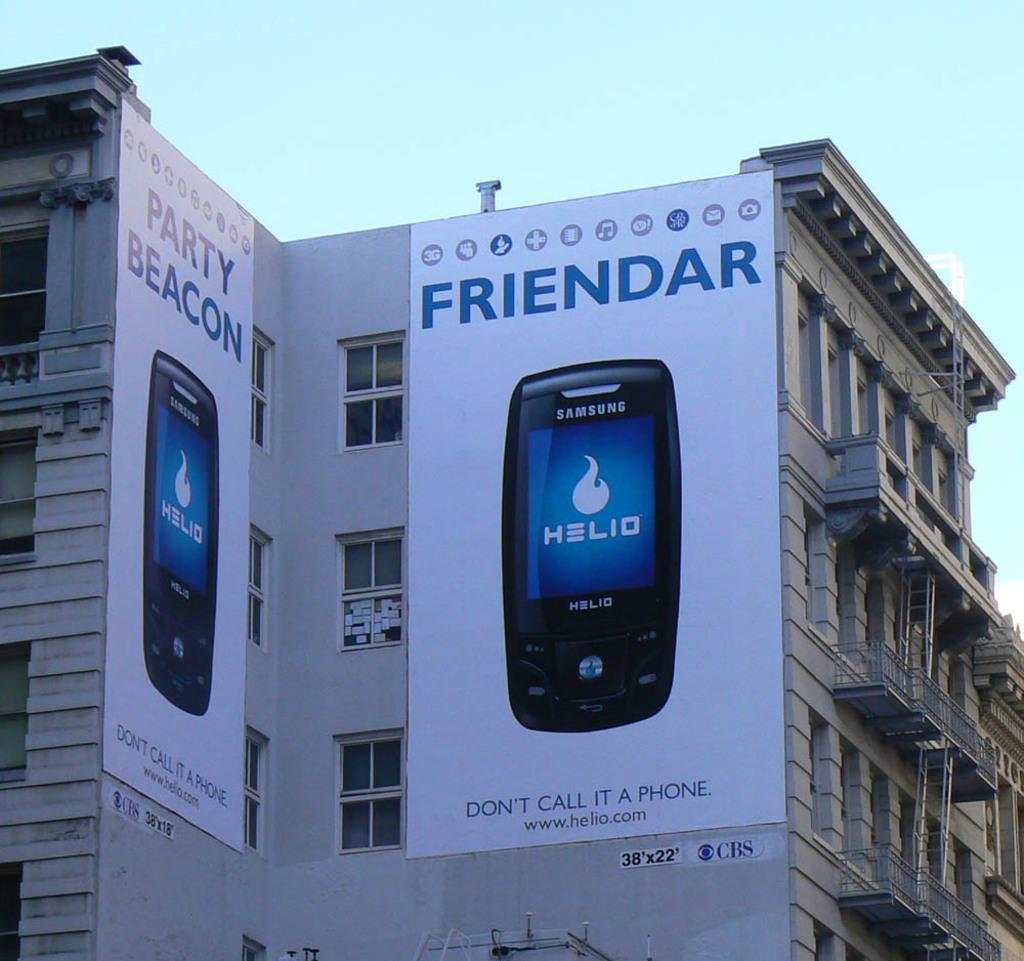Provide a one-sentence caption for the provided image. An advertisement poster for a phone company named Friendar. 